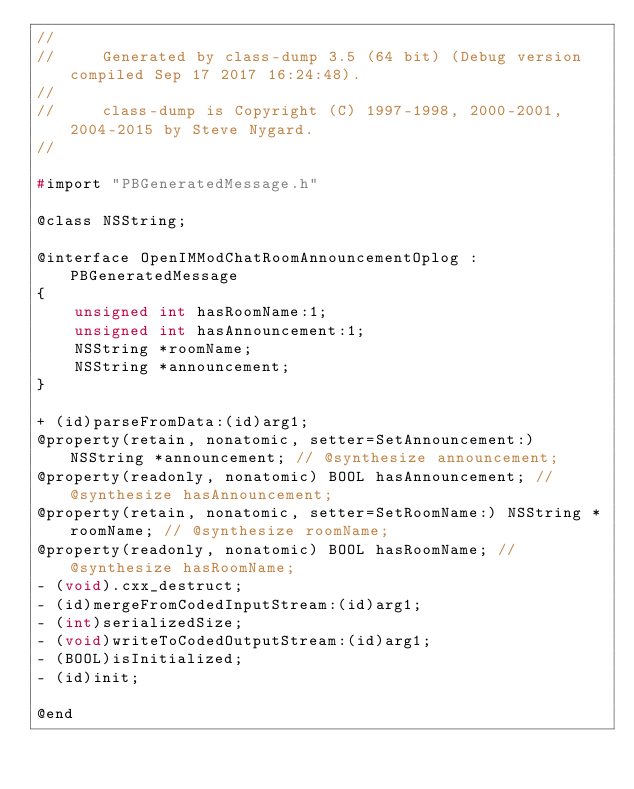Convert code to text. <code><loc_0><loc_0><loc_500><loc_500><_C_>//
//     Generated by class-dump 3.5 (64 bit) (Debug version compiled Sep 17 2017 16:24:48).
//
//     class-dump is Copyright (C) 1997-1998, 2000-2001, 2004-2015 by Steve Nygard.
//

#import "PBGeneratedMessage.h"

@class NSString;

@interface OpenIMModChatRoomAnnouncementOplog : PBGeneratedMessage
{
    unsigned int hasRoomName:1;
    unsigned int hasAnnouncement:1;
    NSString *roomName;
    NSString *announcement;
}

+ (id)parseFromData:(id)arg1;
@property(retain, nonatomic, setter=SetAnnouncement:) NSString *announcement; // @synthesize announcement;
@property(readonly, nonatomic) BOOL hasAnnouncement; // @synthesize hasAnnouncement;
@property(retain, nonatomic, setter=SetRoomName:) NSString *roomName; // @synthesize roomName;
@property(readonly, nonatomic) BOOL hasRoomName; // @synthesize hasRoomName;
- (void).cxx_destruct;
- (id)mergeFromCodedInputStream:(id)arg1;
- (int)serializedSize;
- (void)writeToCodedOutputStream:(id)arg1;
- (BOOL)isInitialized;
- (id)init;

@end

</code> 